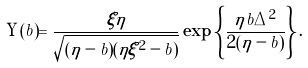Convert formula to latex. <formula><loc_0><loc_0><loc_500><loc_500>\Upsilon ( b ) = \frac { \xi \eta } { \sqrt { ( \eta - b ) ( \eta \xi ^ { 2 } - b ) } } \exp \left \{ \frac { \eta b \Delta ^ { 2 } } { 2 ( \eta - b ) } \right \} .</formula> 